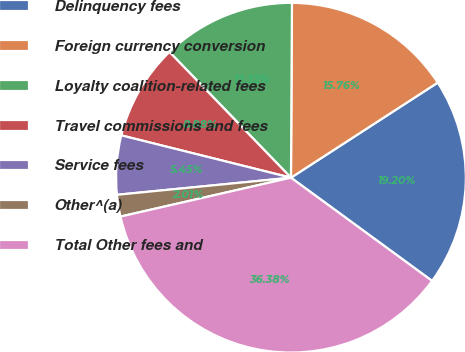<chart> <loc_0><loc_0><loc_500><loc_500><pie_chart><fcel>Delinquency fees<fcel>Foreign currency conversion<fcel>Loyalty coalition-related fees<fcel>Travel commissions and fees<fcel>Service fees<fcel>Other^(a)<fcel>Total Other fees and<nl><fcel>19.2%<fcel>15.76%<fcel>12.32%<fcel>8.88%<fcel>5.45%<fcel>2.01%<fcel>36.38%<nl></chart> 